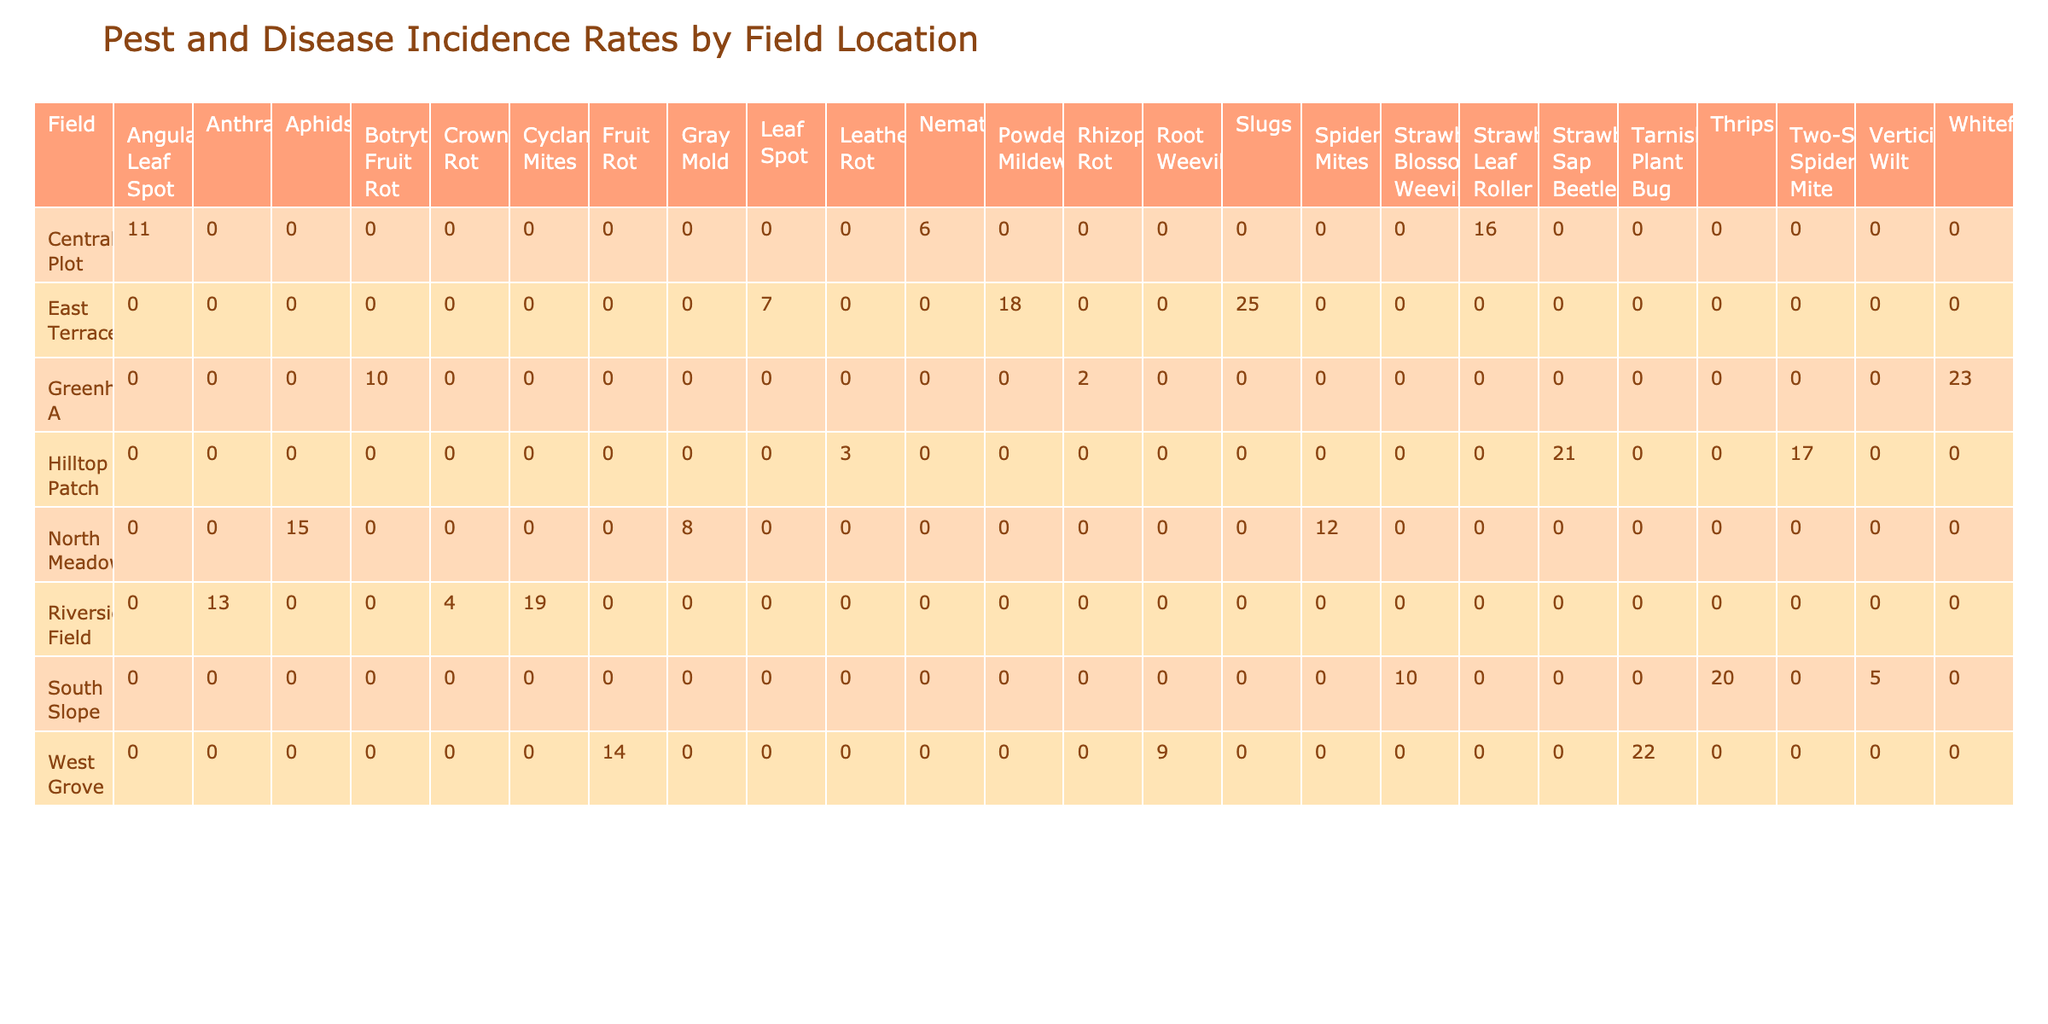What is the incidence rate of Spider Mites in the North Meadow? The table indicates that the incidence rate of Spider Mites in the North Meadow is 12.
Answer: 12 Which field has the highest incidence rate for Thrips? Looking at the table, the South Slope has the highest incidence rate for Thrips, which is 20.
Answer: 20 What is the total incidence rate of diseases for East Terrace? From the table, the incidence rates for East Terrace are Powdery Mildew (18), Slugs (25), and Leaf Spot (7). Summing these gives 18 + 25 + 7 = 50.
Answer: 50 Is the incidence rate of Strawberry Blossom Weevil in South Slope higher than that of Crown Rot in Riverside Field? The incidence rate for Strawberry Blossom Weevil in South Slope is 10, while Crown Rot in Riverside Field has an incidence rate of 4. Since 10 is greater than 4, the statement is true.
Answer: Yes What is the average incidence rate of pests and diseases across all fields? To find the average incidence rate, we will sum all the incidence rates from the table: (12 + 8 + 15 + 20 + 5 + 10 + 18 + 25 + 7 + 14 + 22 + 9 + 16 + 11 + 6 + 13 + 19 + 4 + 21 + 3 + 17 + 23 + 10 + 2) = 320. There are 24 entries, thus the average = 320 / 24 = 13.33.
Answer: 13.33 